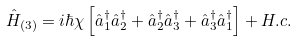<formula> <loc_0><loc_0><loc_500><loc_500>\hat { H } _ { ( 3 ) } = i \hbar { \chi } \left [ \hat { a } _ { 1 } ^ { \dag } \hat { a } _ { 2 } ^ { \dag } + \hat { a } _ { 2 } ^ { \dag } \hat { a } _ { 3 } ^ { \dag } + \hat { a } _ { 3 } ^ { \dag } \hat { a } _ { 1 } ^ { \dag } \right ] + H . c .</formula> 